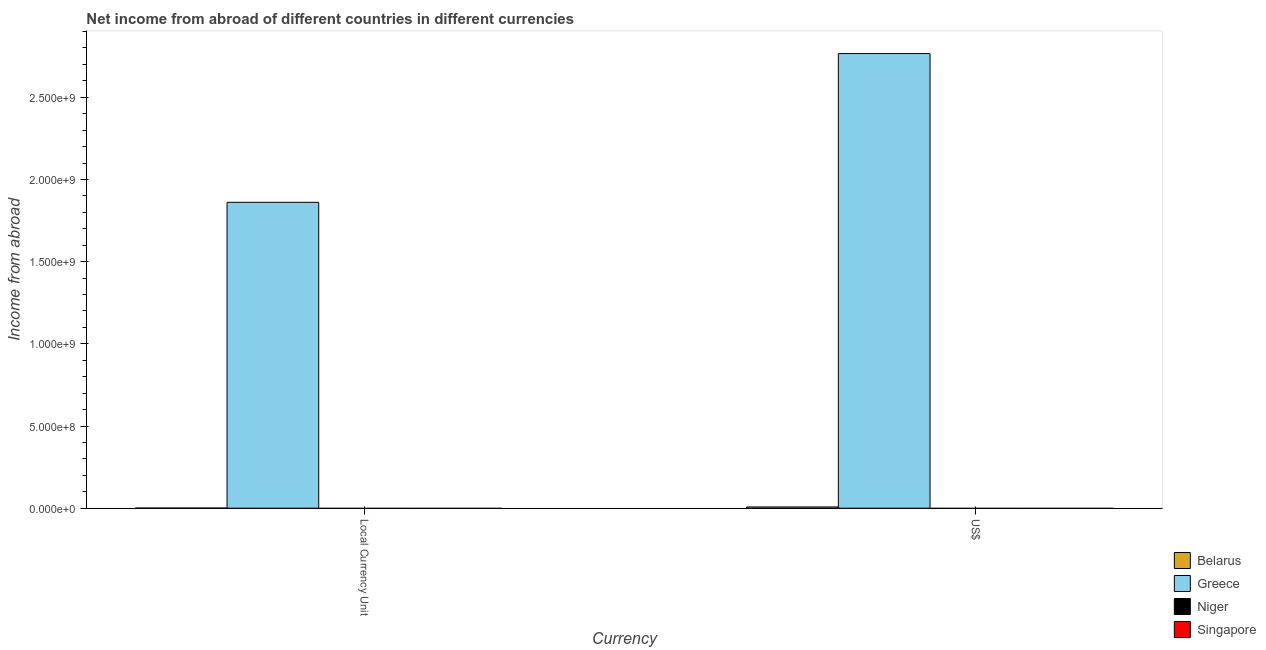Are the number of bars per tick equal to the number of legend labels?
Offer a very short reply. No. What is the label of the 2nd group of bars from the left?
Provide a short and direct response. US$. Across all countries, what is the maximum income from abroad in constant 2005 us$?
Make the answer very short. 1.86e+09. Across all countries, what is the minimum income from abroad in us$?
Provide a short and direct response. 0. In which country was the income from abroad in constant 2005 us$ maximum?
Make the answer very short. Greece. What is the total income from abroad in constant 2005 us$ in the graph?
Your response must be concise. 1.86e+09. What is the difference between the income from abroad in constant 2005 us$ in Greece and that in Belarus?
Keep it short and to the point. 1.86e+09. What is the difference between the income from abroad in us$ in Belarus and the income from abroad in constant 2005 us$ in Niger?
Offer a terse response. 7.60e+06. What is the average income from abroad in constant 2005 us$ per country?
Make the answer very short. 4.65e+08. What is the difference between the income from abroad in constant 2005 us$ and income from abroad in us$ in Greece?
Ensure brevity in your answer.  -9.05e+08. What is the ratio of the income from abroad in us$ in Belarus to that in Greece?
Provide a succinct answer. 0. How many countries are there in the graph?
Your response must be concise. 4. What is the difference between two consecutive major ticks on the Y-axis?
Offer a terse response. 5.00e+08. Does the graph contain any zero values?
Your answer should be very brief. Yes. How are the legend labels stacked?
Your answer should be compact. Vertical. What is the title of the graph?
Your response must be concise. Net income from abroad of different countries in different currencies. What is the label or title of the X-axis?
Offer a terse response. Currency. What is the label or title of the Y-axis?
Give a very brief answer. Income from abroad. What is the Income from abroad of Greece in Local Currency Unit?
Your answer should be compact. 1.86e+09. What is the Income from abroad of Singapore in Local Currency Unit?
Your answer should be very brief. 0. What is the Income from abroad in Belarus in US$?
Your answer should be compact. 7.60e+06. What is the Income from abroad of Greece in US$?
Offer a very short reply. 2.77e+09. What is the Income from abroad of Niger in US$?
Your answer should be compact. 0. What is the Income from abroad in Singapore in US$?
Your answer should be compact. 0. Across all Currency, what is the maximum Income from abroad of Belarus?
Offer a very short reply. 7.60e+06. Across all Currency, what is the maximum Income from abroad in Greece?
Provide a succinct answer. 2.77e+09. Across all Currency, what is the minimum Income from abroad in Greece?
Provide a short and direct response. 1.86e+09. What is the total Income from abroad in Belarus in the graph?
Keep it short and to the point. 8.06e+06. What is the total Income from abroad in Greece in the graph?
Ensure brevity in your answer.  4.63e+09. What is the total Income from abroad in Niger in the graph?
Keep it short and to the point. 0. What is the difference between the Income from abroad in Belarus in Local Currency Unit and that in US$?
Your response must be concise. -7.14e+06. What is the difference between the Income from abroad of Greece in Local Currency Unit and that in US$?
Your answer should be compact. -9.05e+08. What is the difference between the Income from abroad in Belarus in Local Currency Unit and the Income from abroad in Greece in US$?
Provide a short and direct response. -2.77e+09. What is the average Income from abroad in Belarus per Currency?
Provide a succinct answer. 4.03e+06. What is the average Income from abroad of Greece per Currency?
Ensure brevity in your answer.  2.31e+09. What is the average Income from abroad in Niger per Currency?
Your answer should be compact. 0. What is the average Income from abroad of Singapore per Currency?
Provide a short and direct response. 0. What is the difference between the Income from abroad of Belarus and Income from abroad of Greece in Local Currency Unit?
Provide a succinct answer. -1.86e+09. What is the difference between the Income from abroad of Belarus and Income from abroad of Greece in US$?
Your answer should be very brief. -2.76e+09. What is the ratio of the Income from abroad of Belarus in Local Currency Unit to that in US$?
Your response must be concise. 0.06. What is the ratio of the Income from abroad of Greece in Local Currency Unit to that in US$?
Offer a terse response. 0.67. What is the difference between the highest and the second highest Income from abroad in Belarus?
Your answer should be very brief. 7.14e+06. What is the difference between the highest and the second highest Income from abroad of Greece?
Your answer should be compact. 9.05e+08. What is the difference between the highest and the lowest Income from abroad in Belarus?
Provide a succinct answer. 7.14e+06. What is the difference between the highest and the lowest Income from abroad of Greece?
Keep it short and to the point. 9.05e+08. 